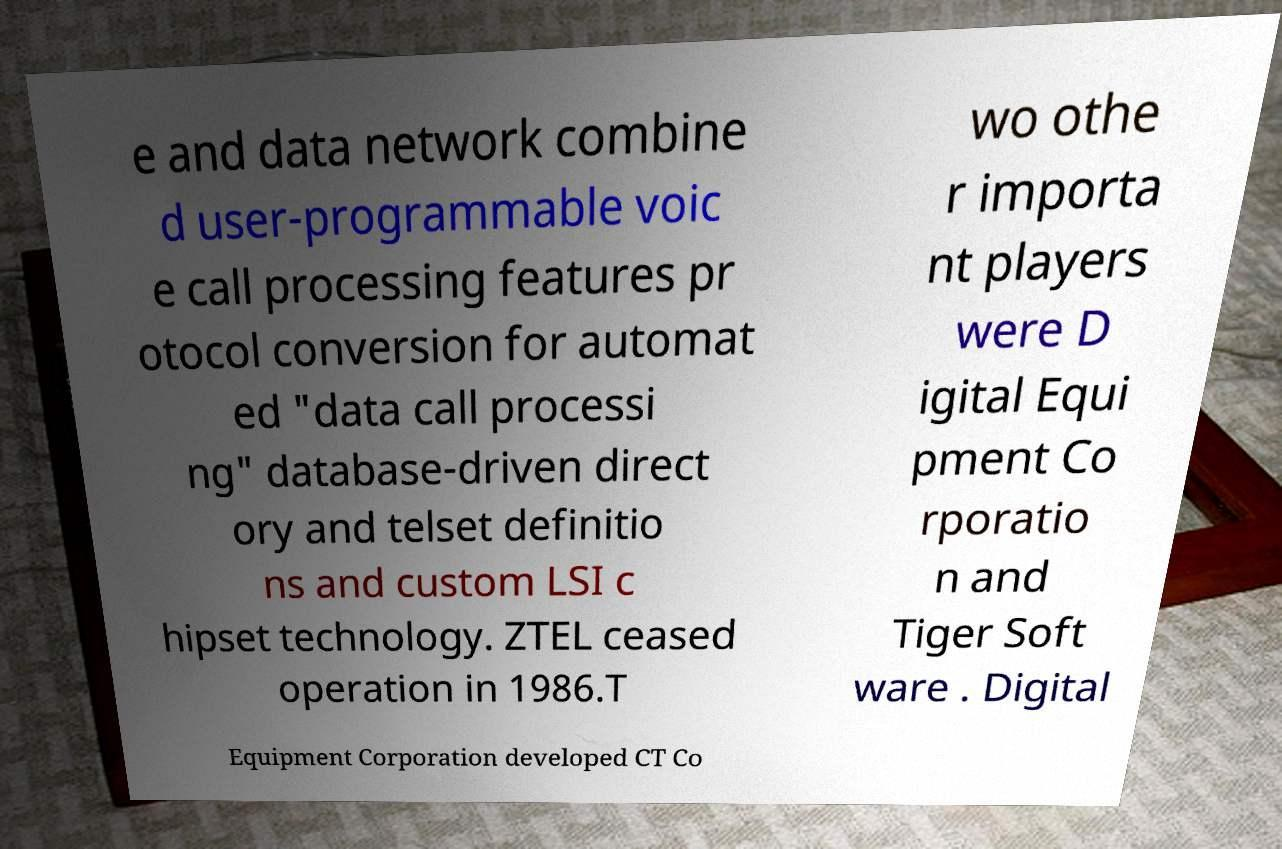There's text embedded in this image that I need extracted. Can you transcribe it verbatim? e and data network combine d user-programmable voic e call processing features pr otocol conversion for automat ed "data call processi ng" database-driven direct ory and telset definitio ns and custom LSI c hipset technology. ZTEL ceased operation in 1986.T wo othe r importa nt players were D igital Equi pment Co rporatio n and Tiger Soft ware . Digital Equipment Corporation developed CT Co 